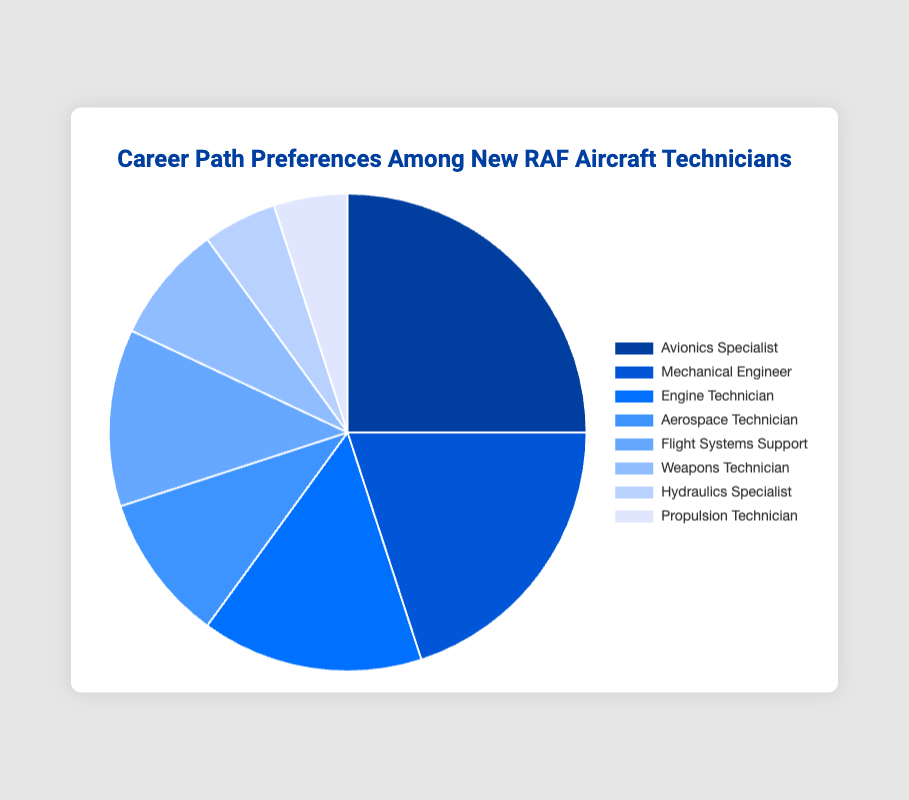Which career path has the highest percentage among new RAF aircraft technicians? The career path with the highest percentage can be identified by looking for the slice of the pie chart that is the largest. In this case, the "Avionics Specialist" slice covers 25% of the pie chart.
Answer: Avionics Specialist Which career paths together make up more than 50% of the preferences? To find which career paths altogether account for more than 50%, we need to sum up the percentages until the total exceeds 50%. "Avionics Specialist" (25%) + "Mechanical Engineer" (20%) + "Engine Technician" (15%) = 60%. These three career paths together make up more than 50%.
Answer: Avionics Specialist, Mechanical Engineer, Engine Technician What is the percentage difference between "Avionics Specialist" and "Aerospace Technician"? The percentage for "Avionics Specialist" is 25%, and for "Aerospace Technician" it is 10%. Subtracting the smaller percentage from the larger gives the difference: 25% - 10% = 15%.
Answer: 15% How does the proportion of "Flight Systems Support" compare to "Weapons Technician"? "Flight Systems Support" accounts for 12% of the pie chart, while "Weapons Technician" accounts for 8%. Comparing these values, "Flight Systems Support" is greater than "Weapons Technician" by 4%.
Answer: Flight Systems Support is greater Which two career paths have the lowest percentages and what is their combined percentage? Identifying the smallest slices of the pie chart, "Hydraulics Specialist" and "Propulsion Technician" each account for 5%. Adding their percentages: 5% + 5% = 10%.
Answer: Hydraulics Specialist, Propulsion Technician, 10% What is the visual color representing the "Mechanical Engineer" career path? The "Mechanical Engineer" slice of the pie chart can be identified by its position and the corresponding color it is filled with. The slice is the second largest and is colored in a shade of blue (#0056d6).
Answer: Blue What is the combined percentage of "Avionics Specialist", "Mechanical Engineer", and "Engine Technician"? Summing the percentages for these three career paths: "Avionics Specialist" (25%) + "Mechanical Engineer" (20%) + "Engine Technician" (15%) = 60%.
Answer: 60% How much greater is the percentage of "Mechanical Engineer" compared to "Weapons Technician"? "Mechanical Engineer" accounts for 20% and "Weapons Technician" accounts for 8%. The difference is 20% - 8% = 12%.
Answer: 12% If we combine the percentages of "Flight Systems Support" and "Aerospace Technician", what fraction of the pie chart do they represent? Adding the percentages of these two career paths: "Flight Systems Support" (12%) + "Aerospace Technician" (10%) = 22%. To express this as a fraction of the whole pie chart, 22 out of 100 or 22/100 simplifies to 11/50.
Answer: 11/50 